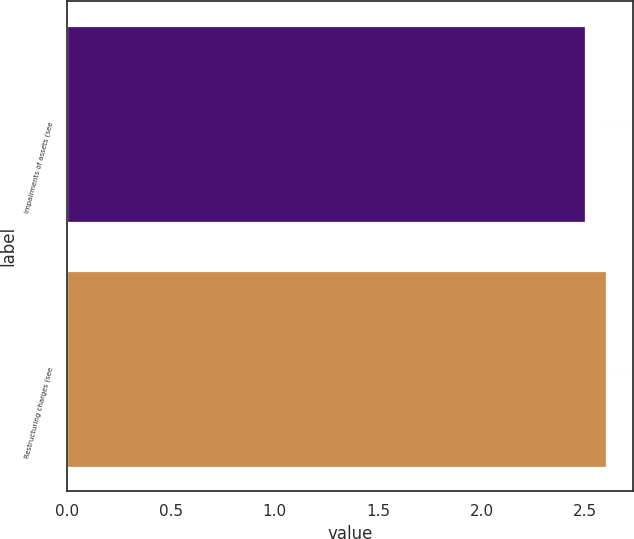<chart> <loc_0><loc_0><loc_500><loc_500><bar_chart><fcel>Impairments of assets (see<fcel>Restructuring charges (see<nl><fcel>2.5<fcel>2.6<nl></chart> 